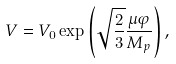Convert formula to latex. <formula><loc_0><loc_0><loc_500><loc_500>V = V _ { 0 } \exp \left ( \sqrt { \frac { 2 } { 3 } } \frac { \mu \varphi } { M _ { p } } \right ) ,</formula> 